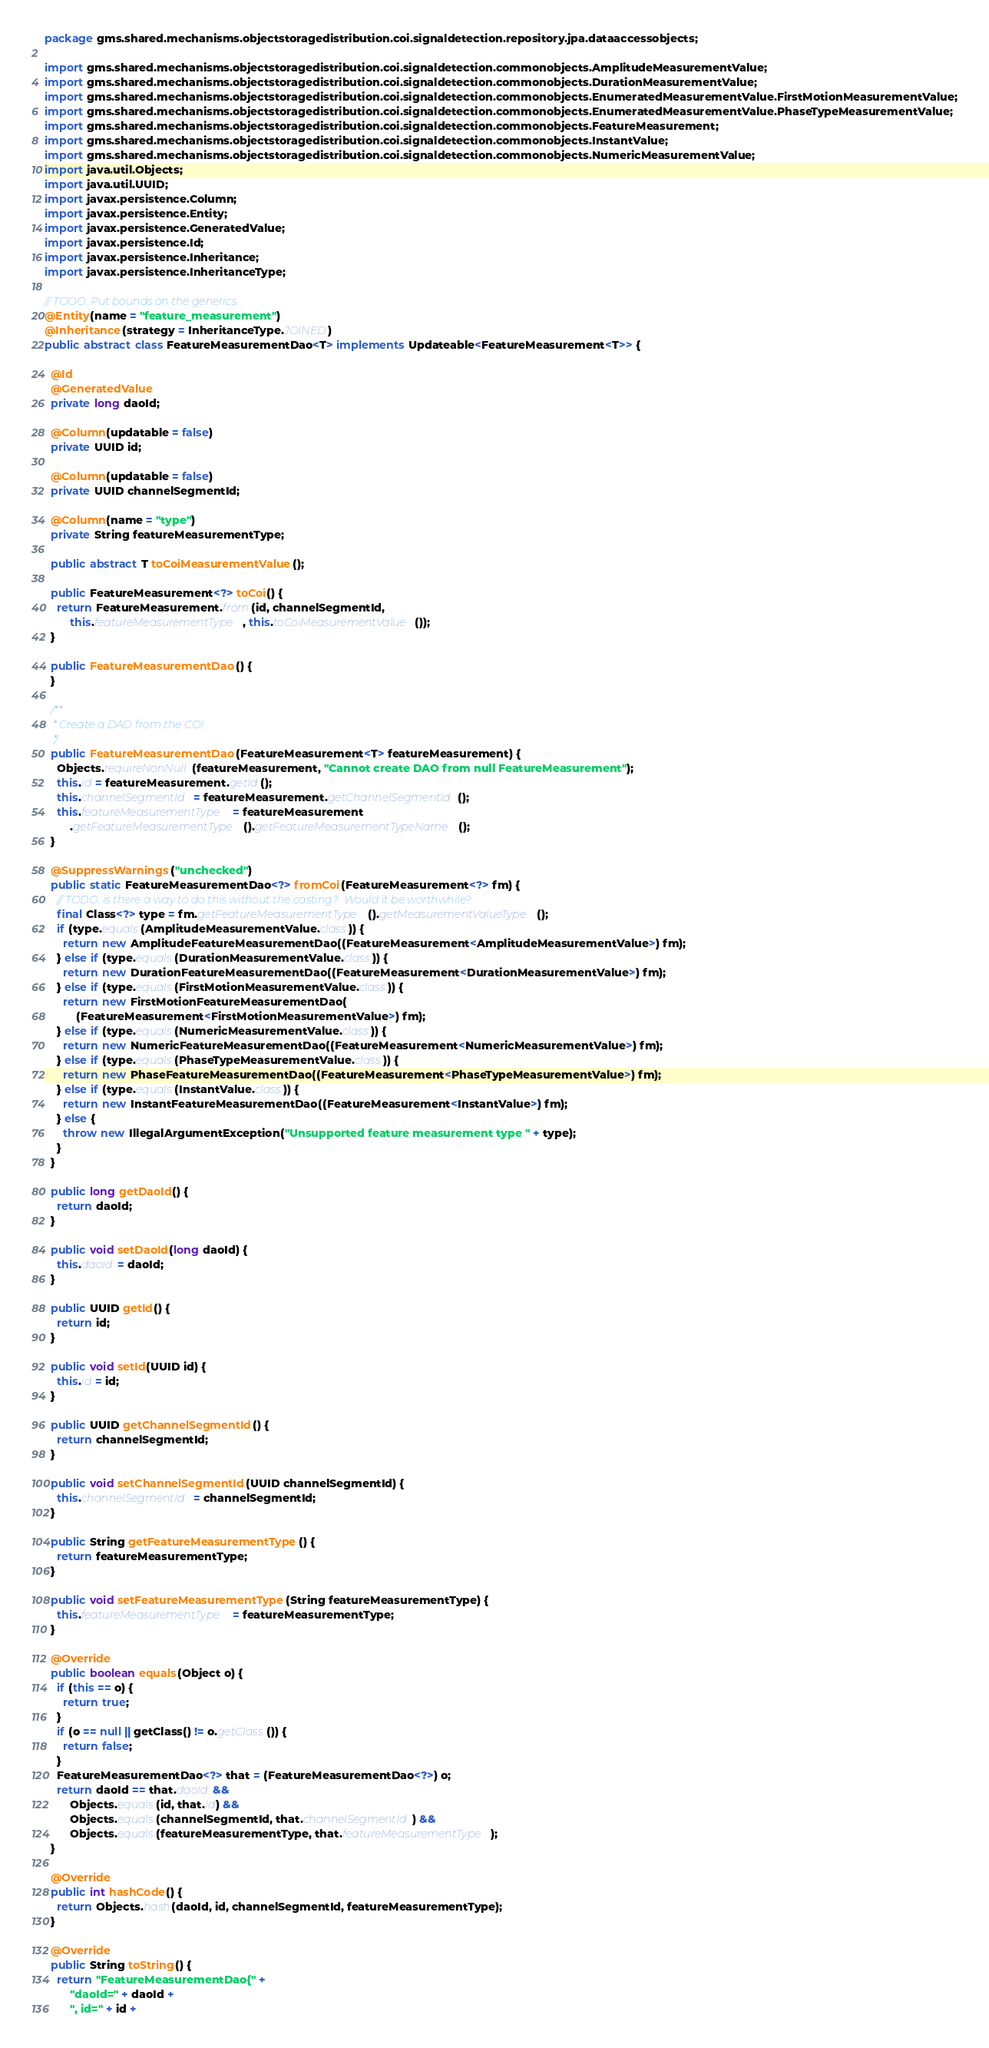<code> <loc_0><loc_0><loc_500><loc_500><_Java_>package gms.shared.mechanisms.objectstoragedistribution.coi.signaldetection.repository.jpa.dataaccessobjects;

import gms.shared.mechanisms.objectstoragedistribution.coi.signaldetection.commonobjects.AmplitudeMeasurementValue;
import gms.shared.mechanisms.objectstoragedistribution.coi.signaldetection.commonobjects.DurationMeasurementValue;
import gms.shared.mechanisms.objectstoragedistribution.coi.signaldetection.commonobjects.EnumeratedMeasurementValue.FirstMotionMeasurementValue;
import gms.shared.mechanisms.objectstoragedistribution.coi.signaldetection.commonobjects.EnumeratedMeasurementValue.PhaseTypeMeasurementValue;
import gms.shared.mechanisms.objectstoragedistribution.coi.signaldetection.commonobjects.FeatureMeasurement;
import gms.shared.mechanisms.objectstoragedistribution.coi.signaldetection.commonobjects.InstantValue;
import gms.shared.mechanisms.objectstoragedistribution.coi.signaldetection.commonobjects.NumericMeasurementValue;
import java.util.Objects;
import java.util.UUID;
import javax.persistence.Column;
import javax.persistence.Entity;
import javax.persistence.GeneratedValue;
import javax.persistence.Id;
import javax.persistence.Inheritance;
import javax.persistence.InheritanceType;

// TOOO: Put bounds on the generics
@Entity(name = "feature_measurement")
@Inheritance(strategy = InheritanceType.JOINED)
public abstract class FeatureMeasurementDao<T> implements Updateable<FeatureMeasurement<T>> {

  @Id
  @GeneratedValue
  private long daoId;

  @Column(updatable = false)
  private UUID id;

  @Column(updatable = false)
  private UUID channelSegmentId;

  @Column(name = "type")
  private String featureMeasurementType;

  public abstract T toCoiMeasurementValue();

  public FeatureMeasurement<?> toCoi() {
    return FeatureMeasurement.from(id, channelSegmentId,
        this.featureMeasurementType, this.toCoiMeasurementValue());
  }

  public FeatureMeasurementDao() {
  }

  /**
   * Create a DAO from the COI.
   */
  public FeatureMeasurementDao(FeatureMeasurement<T> featureMeasurement) {
    Objects.requireNonNull(featureMeasurement, "Cannot create DAO from null FeatureMeasurement");
    this.id = featureMeasurement.getId();
    this.channelSegmentId = featureMeasurement.getChannelSegmentId();
    this.featureMeasurementType = featureMeasurement
        .getFeatureMeasurementType().getFeatureMeasurementTypeName();
  }

  @SuppressWarnings("unchecked")
  public static FeatureMeasurementDao<?> fromCoi(FeatureMeasurement<?> fm) {
    // TODO: is there a way to do this without the casting?  Would it be worthwhile?
    final Class<?> type = fm.getFeatureMeasurementType().getMeasurementValueType();
    if (type.equals(AmplitudeMeasurementValue.class)) {
      return new AmplitudeFeatureMeasurementDao((FeatureMeasurement<AmplitudeMeasurementValue>) fm);
    } else if (type.equals(DurationMeasurementValue.class)) {
      return new DurationFeatureMeasurementDao((FeatureMeasurement<DurationMeasurementValue>) fm);
    } else if (type.equals(FirstMotionMeasurementValue.class)) {
      return new FirstMotionFeatureMeasurementDao(
          (FeatureMeasurement<FirstMotionMeasurementValue>) fm);
    } else if (type.equals(NumericMeasurementValue.class)) {
      return new NumericFeatureMeasurementDao((FeatureMeasurement<NumericMeasurementValue>) fm);
    } else if (type.equals(PhaseTypeMeasurementValue.class)) {
      return new PhaseFeatureMeasurementDao((FeatureMeasurement<PhaseTypeMeasurementValue>) fm);
    } else if (type.equals(InstantValue.class)) {
      return new InstantFeatureMeasurementDao((FeatureMeasurement<InstantValue>) fm);
    } else {
      throw new IllegalArgumentException("Unsupported feature measurement type " + type);
    }
  }

  public long getDaoId() {
    return daoId;
  }

  public void setDaoId(long daoId) {
    this.daoId = daoId;
  }

  public UUID getId() {
    return id;
  }

  public void setId(UUID id) {
    this.id = id;
  }

  public UUID getChannelSegmentId() {
    return channelSegmentId;
  }

  public void setChannelSegmentId(UUID channelSegmentId) {
    this.channelSegmentId = channelSegmentId;
  }

  public String getFeatureMeasurementType() {
    return featureMeasurementType;
  }

  public void setFeatureMeasurementType(String featureMeasurementType) {
    this.featureMeasurementType = featureMeasurementType;
  }

  @Override
  public boolean equals(Object o) {
    if (this == o) {
      return true;
    }
    if (o == null || getClass() != o.getClass()) {
      return false;
    }
    FeatureMeasurementDao<?> that = (FeatureMeasurementDao<?>) o;
    return daoId == that.daoId &&
        Objects.equals(id, that.id) &&
        Objects.equals(channelSegmentId, that.channelSegmentId) &&
        Objects.equals(featureMeasurementType, that.featureMeasurementType);
  }

  @Override
  public int hashCode() {
    return Objects.hash(daoId, id, channelSegmentId, featureMeasurementType);
  }

  @Override
  public String toString() {
    return "FeatureMeasurementDao{" +
        "daoId=" + daoId +
        ", id=" + id +</code> 